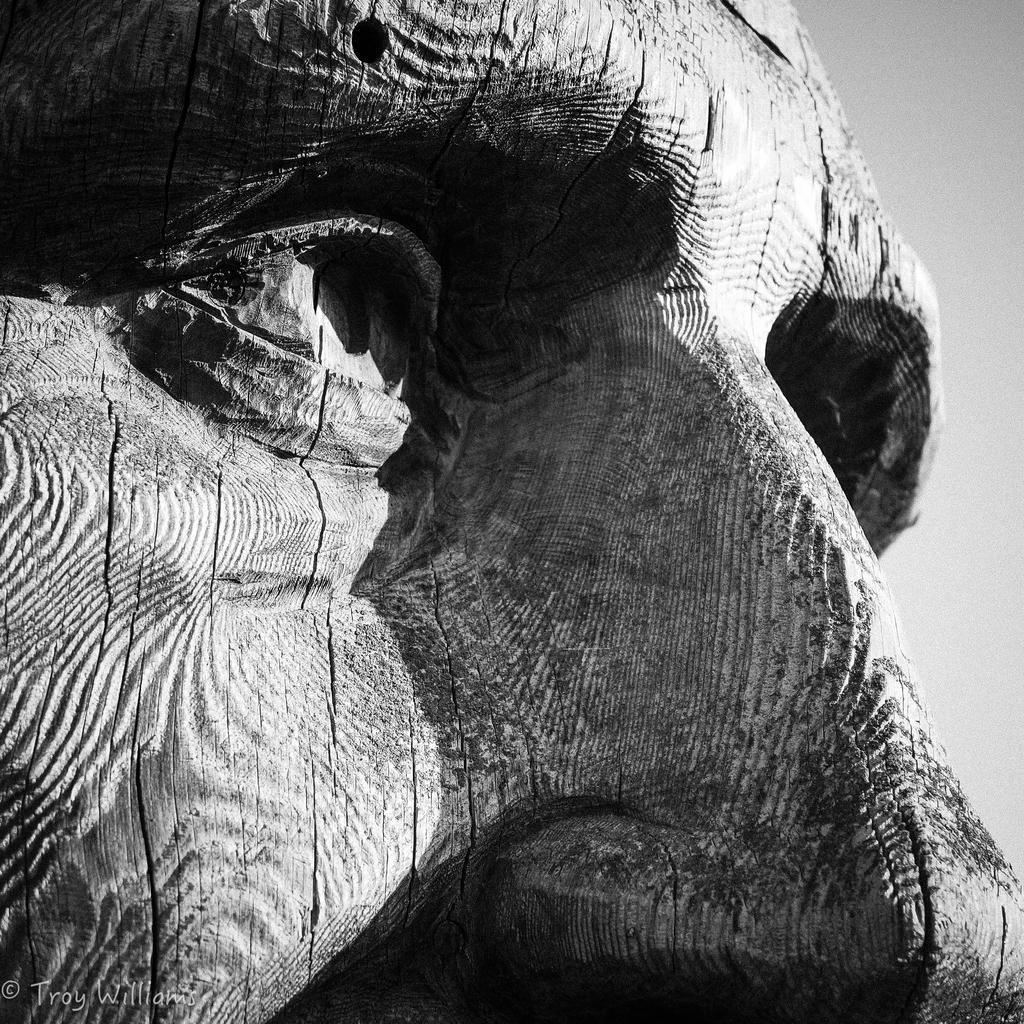What is the color scheme of the image? The image is black and white. What can be seen in the image besides the color scheme? There is a statue of a person in the image. Are there any additional features or marks on the image? Yes, there is a watermark on the image. What type of advice is the person in the statue giving in the image? There is no indication of the person in the statue giving advice in the image, as it is a statue and not a living person. 